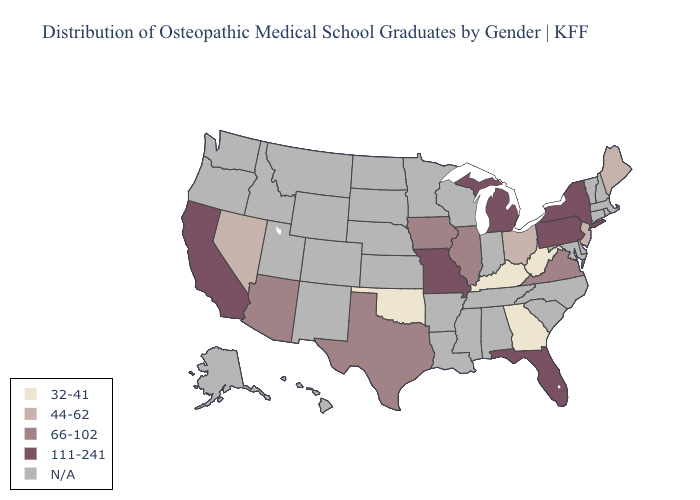Name the states that have a value in the range 66-102?
Write a very short answer. Arizona, Illinois, Iowa, Texas, Virginia. Name the states that have a value in the range 111-241?
Be succinct. California, Florida, Michigan, Missouri, New York, Pennsylvania. Does Nevada have the highest value in the West?
Short answer required. No. Which states have the lowest value in the USA?
Give a very brief answer. Georgia, Kentucky, Oklahoma, West Virginia. Name the states that have a value in the range 44-62?
Short answer required. Maine, Nevada, New Jersey, Ohio. Does Texas have the highest value in the South?
Short answer required. No. Does the map have missing data?
Be succinct. Yes. What is the value of Indiana?
Write a very short answer. N/A. What is the lowest value in the USA?
Concise answer only. 32-41. Name the states that have a value in the range 111-241?
Concise answer only. California, Florida, Michigan, Missouri, New York, Pennsylvania. Name the states that have a value in the range 111-241?
Quick response, please. California, Florida, Michigan, Missouri, New York, Pennsylvania. Which states have the highest value in the USA?
Short answer required. California, Florida, Michigan, Missouri, New York, Pennsylvania. Which states have the lowest value in the South?
Be succinct. Georgia, Kentucky, Oklahoma, West Virginia. Name the states that have a value in the range 111-241?
Concise answer only. California, Florida, Michigan, Missouri, New York, Pennsylvania. 